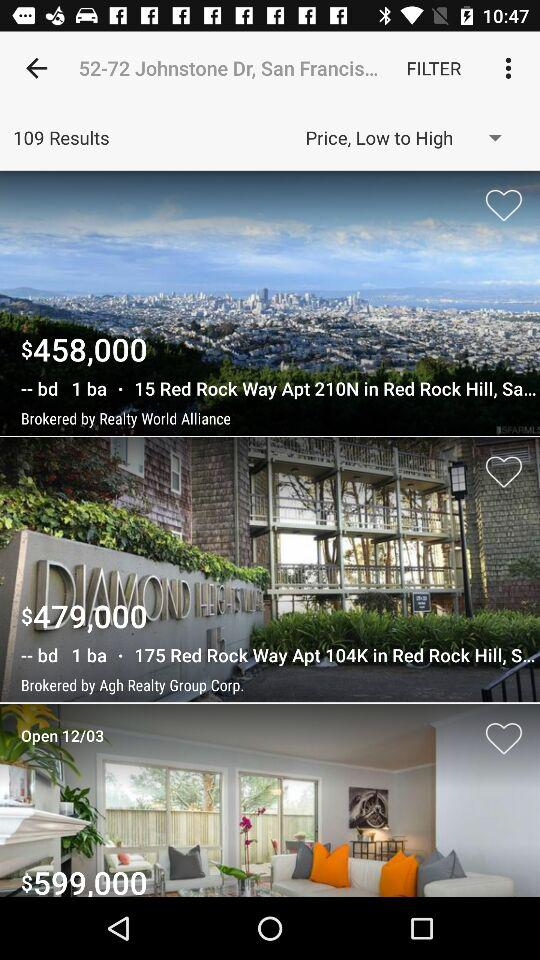How many total results are there? There are 109 results. 